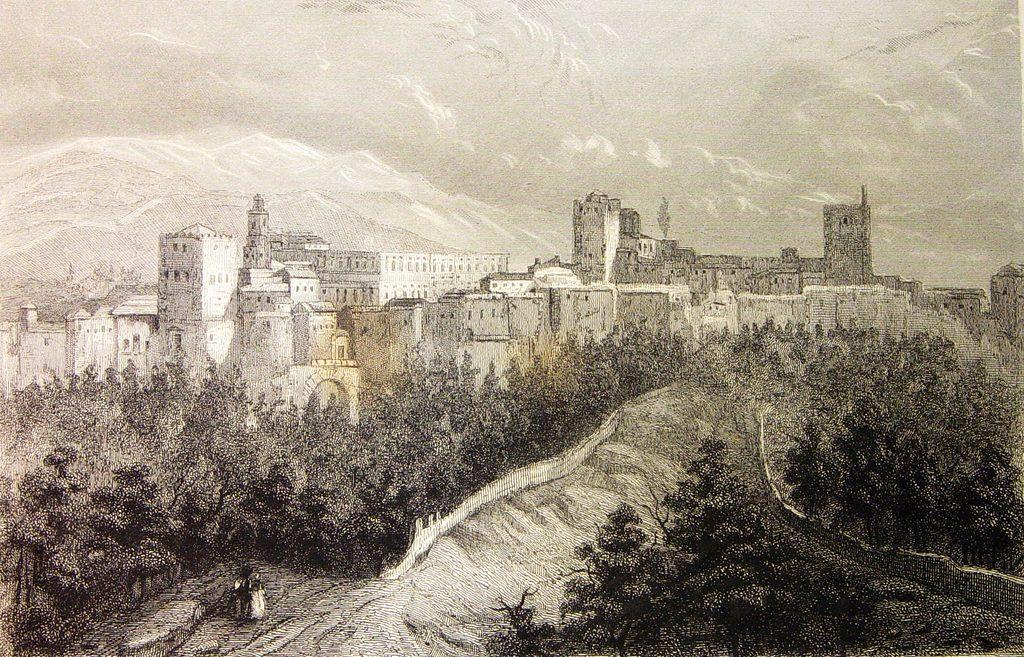Could you give a brief overview of what you see in this image? This image is consists of a sketch. 